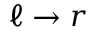<formula> <loc_0><loc_0><loc_500><loc_500>\ell \rightarrow r</formula> 